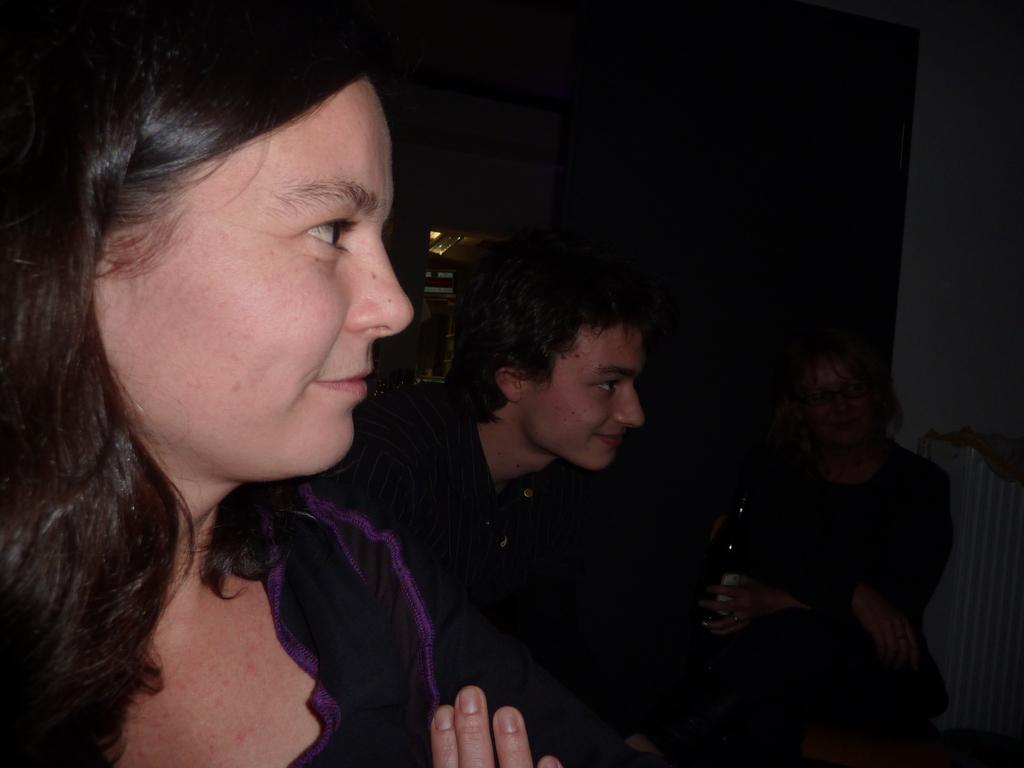How many people are on the left side of the image? There are two persons on the left side of the image. What are the two persons on the left side doing? The two persons on the left side are looking at the right side. Can you describe the person visible in the background of the image? The background person is in a dark area. What type of cakes are being served by the sail on the clover in the image? There are no cakes, sails, or clovers present in the image. 